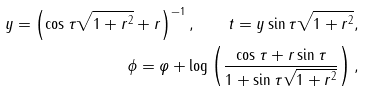Convert formula to latex. <formula><loc_0><loc_0><loc_500><loc_500>y = \left ( \cos \tau \sqrt { 1 + r ^ { 2 } } + r \right ) ^ { - 1 } , \quad t = y \sin \tau \sqrt { 1 + r ^ { 2 } } , \\ \phi = \varphi + \log \left ( \frac { \cos \tau + r \sin \tau } { 1 + \sin \tau \sqrt { 1 + r ^ { 2 } } } \right ) ,</formula> 